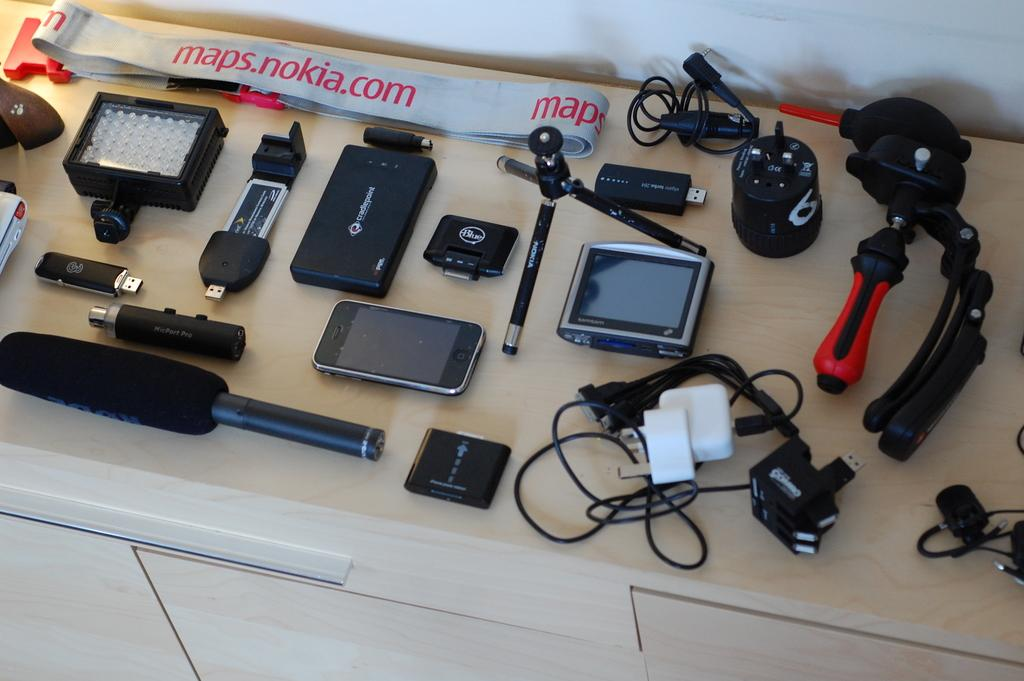<image>
Relay a brief, clear account of the picture shown. Tools are laid out on a table with a strap that says maps.nokia.com 